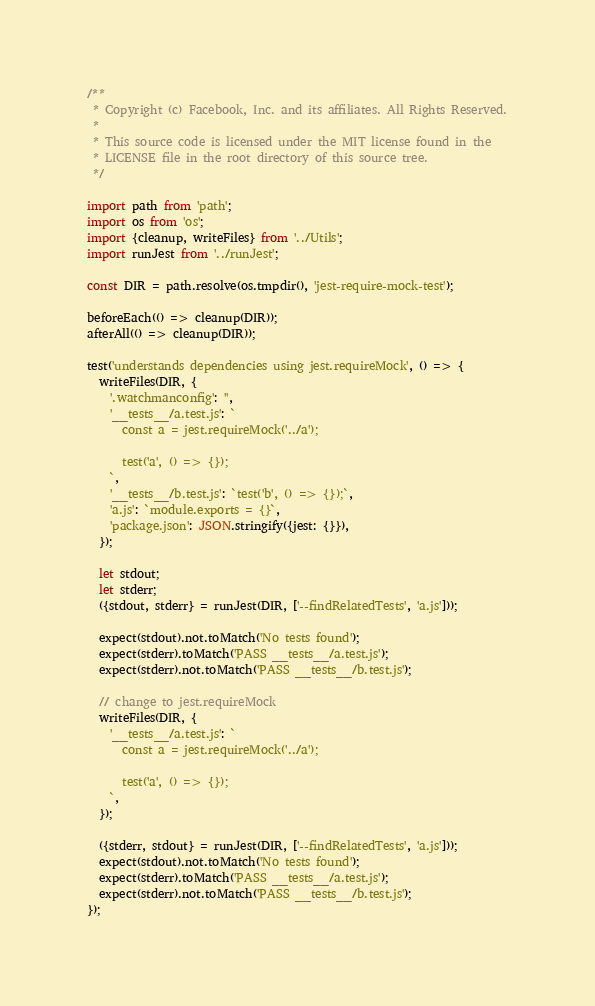Convert code to text. <code><loc_0><loc_0><loc_500><loc_500><_TypeScript_>/**
 * Copyright (c) Facebook, Inc. and its affiliates. All Rights Reserved.
 *
 * This source code is licensed under the MIT license found in the
 * LICENSE file in the root directory of this source tree.
 */

import path from 'path';
import os from 'os';
import {cleanup, writeFiles} from '../Utils';
import runJest from '../runJest';

const DIR = path.resolve(os.tmpdir(), 'jest-require-mock-test');

beforeEach(() => cleanup(DIR));
afterAll(() => cleanup(DIR));

test('understands dependencies using jest.requireMock', () => {
  writeFiles(DIR, {
    '.watchmanconfig': '',
    '__tests__/a.test.js': `
      const a = jest.requireMock('../a');

      test('a', () => {});
    `,
    '__tests__/b.test.js': `test('b', () => {});`,
    'a.js': `module.exports = {}`,
    'package.json': JSON.stringify({jest: {}}),
  });

  let stdout;
  let stderr;
  ({stdout, stderr} = runJest(DIR, ['--findRelatedTests', 'a.js']));

  expect(stdout).not.toMatch('No tests found');
  expect(stderr).toMatch('PASS __tests__/a.test.js');
  expect(stderr).not.toMatch('PASS __tests__/b.test.js');

  // change to jest.requireMock
  writeFiles(DIR, {
    '__tests__/a.test.js': `
      const a = jest.requireMock('../a');

      test('a', () => {});
    `,
  });

  ({stderr, stdout} = runJest(DIR, ['--findRelatedTests', 'a.js']));
  expect(stdout).not.toMatch('No tests found');
  expect(stderr).toMatch('PASS __tests__/a.test.js');
  expect(stderr).not.toMatch('PASS __tests__/b.test.js');
});
</code> 